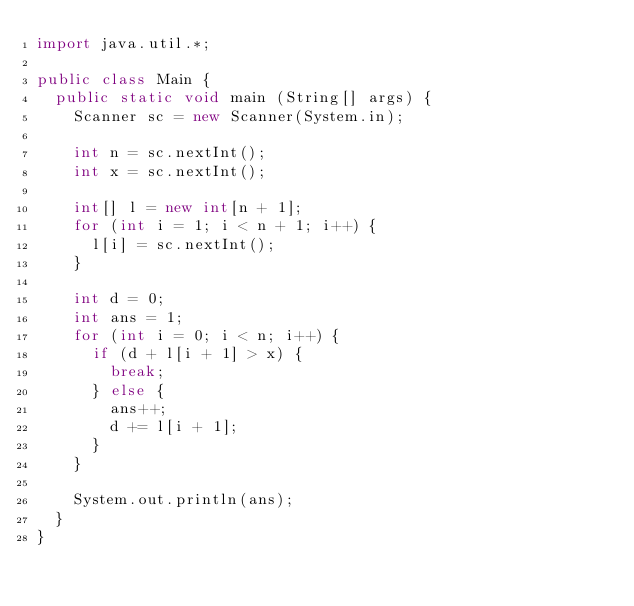Convert code to text. <code><loc_0><loc_0><loc_500><loc_500><_Java_>import java.util.*;

public class Main {
  public static void main (String[] args) {
    Scanner sc = new Scanner(System.in);

    int n = sc.nextInt();
    int x = sc.nextInt();

    int[] l = new int[n + 1];
    for (int i = 1; i < n + 1; i++) {
      l[i] = sc.nextInt();
    }

    int d = 0;
    int ans = 1;
    for (int i = 0; i < n; i++) {
      if (d + l[i + 1] > x) {
        break;
      } else {
        ans++;
        d += l[i + 1];
      }
    }
    
    System.out.println(ans);
  }
}
</code> 